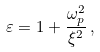Convert formula to latex. <formula><loc_0><loc_0><loc_500><loc_500>\varepsilon = 1 + \frac { \omega _ { p } ^ { 2 } } { \xi ^ { 2 } } \, ,</formula> 